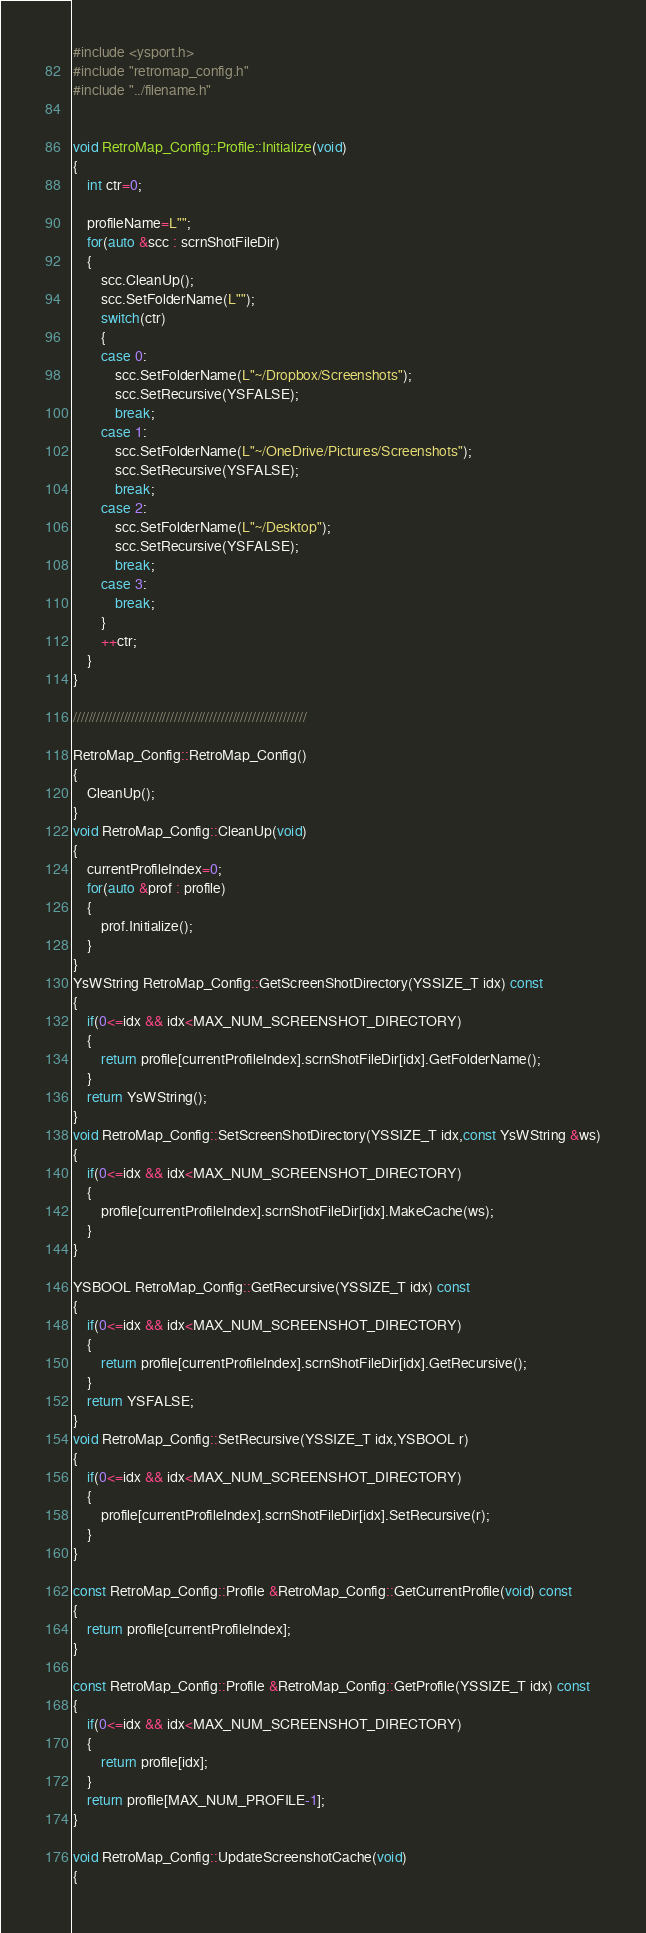<code> <loc_0><loc_0><loc_500><loc_500><_C++_>#include <ysport.h>
#include "retromap_config.h"
#include "../filename.h"


void RetroMap_Config::Profile::Initialize(void)
{
	int ctr=0;

	profileName=L"";
	for(auto &scc : scrnShotFileDir)
	{
		scc.CleanUp();
		scc.SetFolderName(L"");
		switch(ctr)
		{
		case 0:
			scc.SetFolderName(L"~/Dropbox/Screenshots");
			scc.SetRecursive(YSFALSE);
			break;
		case 1:
			scc.SetFolderName(L"~/OneDrive/Pictures/Screenshots");
			scc.SetRecursive(YSFALSE);
			break;
		case 2:
			scc.SetFolderName(L"~/Desktop");
			scc.SetRecursive(YSFALSE);
			break;
		case 3:
			break;
		}
		++ctr;
	}
}

////////////////////////////////////////////////////////////

RetroMap_Config::RetroMap_Config()
{
	CleanUp();
}
void RetroMap_Config::CleanUp(void)
{
	currentProfileIndex=0;
	for(auto &prof : profile)
	{
		prof.Initialize();
	}
}
YsWString RetroMap_Config::GetScreenShotDirectory(YSSIZE_T idx) const
{
	if(0<=idx && idx<MAX_NUM_SCREENSHOT_DIRECTORY)
	{
		return profile[currentProfileIndex].scrnShotFileDir[idx].GetFolderName();
	}
	return YsWString();
}
void RetroMap_Config::SetScreenShotDirectory(YSSIZE_T idx,const YsWString &ws)
{
	if(0<=idx && idx<MAX_NUM_SCREENSHOT_DIRECTORY)
	{
		profile[currentProfileIndex].scrnShotFileDir[idx].MakeCache(ws);
	}
}

YSBOOL RetroMap_Config::GetRecursive(YSSIZE_T idx) const
{
	if(0<=idx && idx<MAX_NUM_SCREENSHOT_DIRECTORY)
	{
		return profile[currentProfileIndex].scrnShotFileDir[idx].GetRecursive();
	}
	return YSFALSE;
}
void RetroMap_Config::SetRecursive(YSSIZE_T idx,YSBOOL r)
{
	if(0<=idx && idx<MAX_NUM_SCREENSHOT_DIRECTORY)
	{
		profile[currentProfileIndex].scrnShotFileDir[idx].SetRecursive(r);
	}
}

const RetroMap_Config::Profile &RetroMap_Config::GetCurrentProfile(void) const
{
	return profile[currentProfileIndex];
}

const RetroMap_Config::Profile &RetroMap_Config::GetProfile(YSSIZE_T idx) const
{
	if(0<=idx && idx<MAX_NUM_SCREENSHOT_DIRECTORY)
	{
		return profile[idx];
	}
	return profile[MAX_NUM_PROFILE-1];
}

void RetroMap_Config::UpdateScreenshotCache(void)
{</code> 